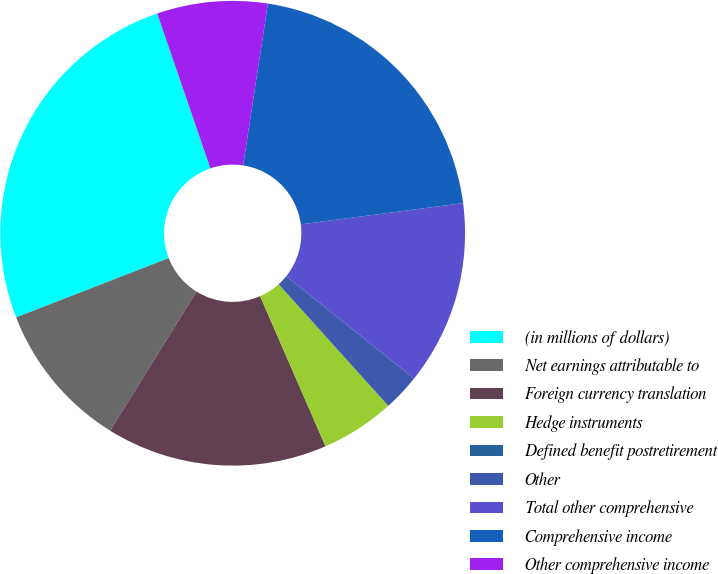<chart> <loc_0><loc_0><loc_500><loc_500><pie_chart><fcel>(in millions of dollars)<fcel>Net earnings attributable to<fcel>Foreign currency translation<fcel>Hedge instruments<fcel>Defined benefit postretirement<fcel>Other<fcel>Total other comprehensive<fcel>Comprehensive income<fcel>Other comprehensive income<nl><fcel>25.63%<fcel>10.26%<fcel>15.38%<fcel>5.13%<fcel>0.01%<fcel>2.57%<fcel>12.82%<fcel>20.51%<fcel>7.69%<nl></chart> 